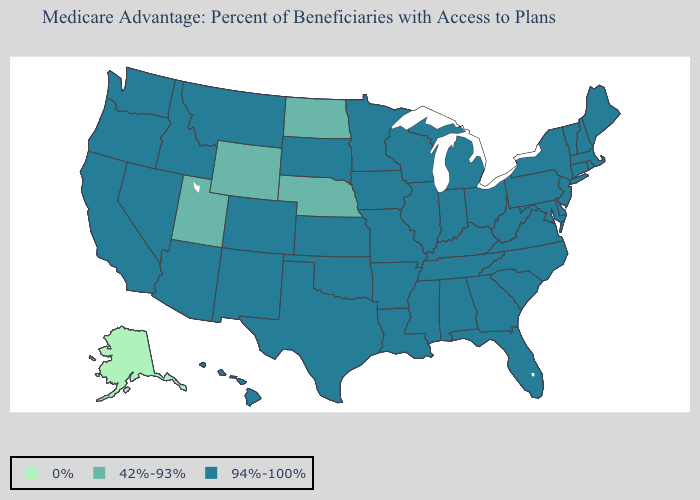Is the legend a continuous bar?
Keep it brief. No. Name the states that have a value in the range 42%-93%?
Short answer required. North Dakota, Nebraska, Utah, Wyoming. What is the lowest value in states that border New York?
Quick response, please. 94%-100%. Which states hav the highest value in the MidWest?
Be succinct. Iowa, Illinois, Indiana, Kansas, Michigan, Minnesota, Missouri, Ohio, South Dakota, Wisconsin. Name the states that have a value in the range 42%-93%?
Quick response, please. North Dakota, Nebraska, Utah, Wyoming. Does Utah have the highest value in the USA?
Short answer required. No. Name the states that have a value in the range 42%-93%?
Short answer required. North Dakota, Nebraska, Utah, Wyoming. Which states hav the highest value in the West?
Keep it brief. California, Colorado, Hawaii, Idaho, Montana, New Mexico, Nevada, Oregon, Washington, Arizona. What is the value of Tennessee?
Be succinct. 94%-100%. Which states hav the highest value in the MidWest?
Quick response, please. Iowa, Illinois, Indiana, Kansas, Michigan, Minnesota, Missouri, Ohio, South Dakota, Wisconsin. Name the states that have a value in the range 94%-100%?
Quick response, please. California, Colorado, Connecticut, Delaware, Florida, Georgia, Hawaii, Iowa, Idaho, Illinois, Indiana, Kansas, Kentucky, Louisiana, Massachusetts, Maryland, Maine, Michigan, Minnesota, Missouri, Mississippi, Montana, North Carolina, New Hampshire, New Jersey, New Mexico, Nevada, New York, Ohio, Oklahoma, Oregon, Pennsylvania, Rhode Island, South Carolina, South Dakota, Tennessee, Texas, Virginia, Vermont, Washington, Wisconsin, West Virginia, Alabama, Arkansas, Arizona. Which states have the lowest value in the Northeast?
Give a very brief answer. Connecticut, Massachusetts, Maine, New Hampshire, New Jersey, New York, Pennsylvania, Rhode Island, Vermont. What is the lowest value in states that border Louisiana?
Concise answer only. 94%-100%. How many symbols are there in the legend?
Answer briefly. 3. 